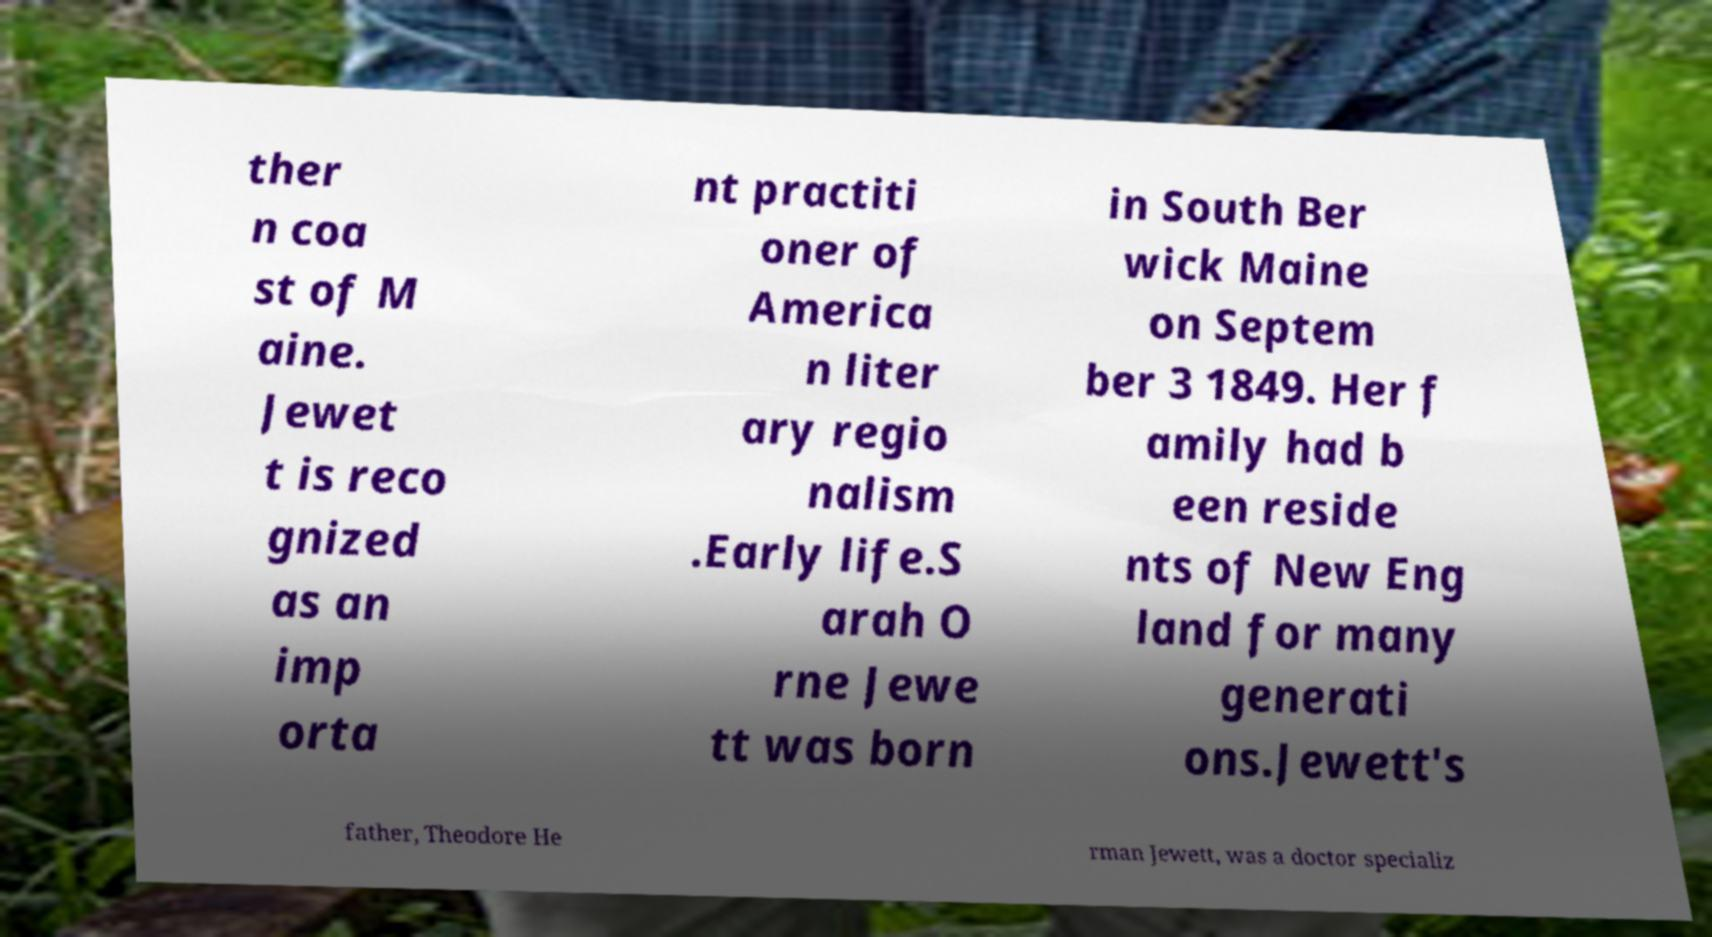Please identify and transcribe the text found in this image. ther n coa st of M aine. Jewet t is reco gnized as an imp orta nt practiti oner of America n liter ary regio nalism .Early life.S arah O rne Jewe tt was born in South Ber wick Maine on Septem ber 3 1849. Her f amily had b een reside nts of New Eng land for many generati ons.Jewett's father, Theodore He rman Jewett, was a doctor specializ 